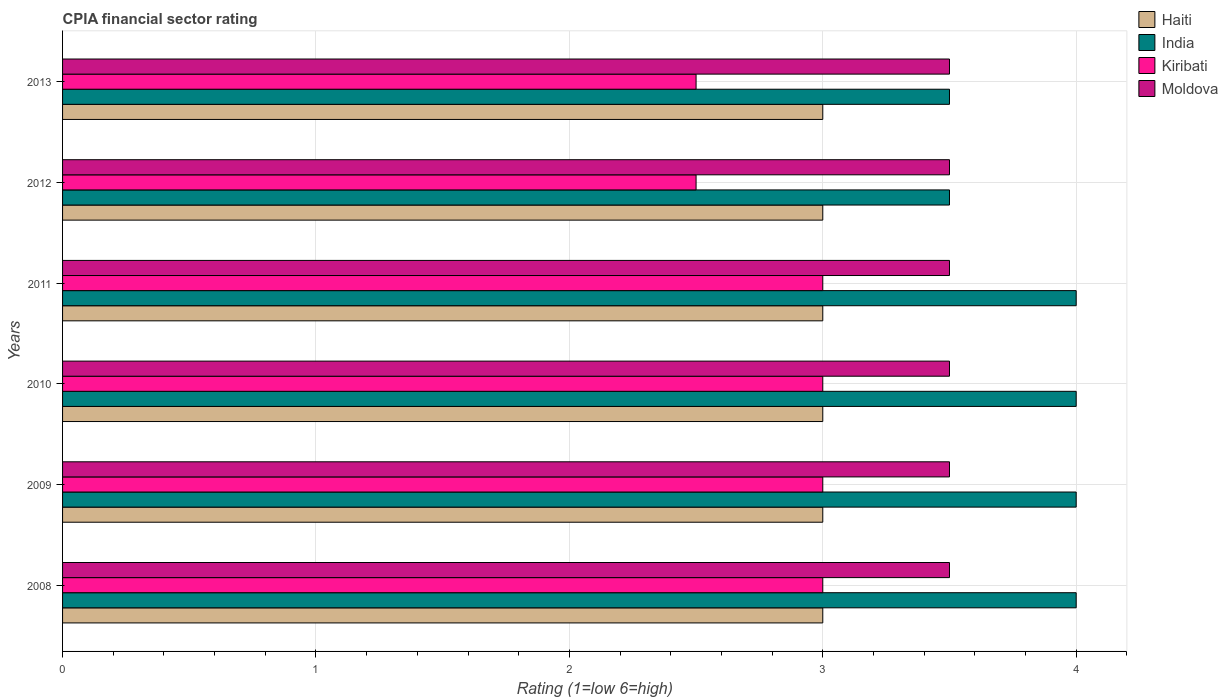How many different coloured bars are there?
Offer a very short reply. 4. Are the number of bars on each tick of the Y-axis equal?
Your answer should be very brief. Yes. What is the label of the 3rd group of bars from the top?
Offer a very short reply. 2011. In how many cases, is the number of bars for a given year not equal to the number of legend labels?
Offer a terse response. 0. What is the CPIA rating in Haiti in 2010?
Give a very brief answer. 3. Across all years, what is the maximum CPIA rating in Haiti?
Offer a very short reply. 3. Across all years, what is the minimum CPIA rating in Haiti?
Give a very brief answer. 3. In which year was the CPIA rating in Haiti maximum?
Your answer should be compact. 2008. In which year was the CPIA rating in Haiti minimum?
Offer a very short reply. 2008. What is the total CPIA rating in Haiti in the graph?
Your response must be concise. 18. What is the difference between the CPIA rating in India in 2010 and the CPIA rating in Kiribati in 2011?
Your response must be concise. 1. What is the average CPIA rating in India per year?
Offer a terse response. 3.83. In how many years, is the CPIA rating in Kiribati greater than 2 ?
Provide a short and direct response. 6. What is the ratio of the CPIA rating in India in 2010 to that in 2012?
Provide a succinct answer. 1.14. Is the CPIA rating in Haiti in 2011 less than that in 2012?
Give a very brief answer. No. Is the difference between the CPIA rating in Moldova in 2010 and 2011 greater than the difference between the CPIA rating in Kiribati in 2010 and 2011?
Ensure brevity in your answer.  No. What does the 4th bar from the top in 2010 represents?
Your answer should be very brief. Haiti. What does the 4th bar from the bottom in 2008 represents?
Give a very brief answer. Moldova. Is it the case that in every year, the sum of the CPIA rating in Moldova and CPIA rating in Haiti is greater than the CPIA rating in Kiribati?
Your answer should be very brief. Yes. Are all the bars in the graph horizontal?
Provide a short and direct response. Yes. How many years are there in the graph?
Make the answer very short. 6. Are the values on the major ticks of X-axis written in scientific E-notation?
Offer a very short reply. No. Where does the legend appear in the graph?
Make the answer very short. Top right. What is the title of the graph?
Give a very brief answer. CPIA financial sector rating. What is the Rating (1=low 6=high) in Kiribati in 2008?
Offer a very short reply. 3. What is the Rating (1=low 6=high) of Haiti in 2009?
Provide a short and direct response. 3. What is the Rating (1=low 6=high) of Moldova in 2009?
Ensure brevity in your answer.  3.5. What is the Rating (1=low 6=high) in Kiribati in 2010?
Provide a succinct answer. 3. What is the Rating (1=low 6=high) of Moldova in 2010?
Give a very brief answer. 3.5. What is the Rating (1=low 6=high) of Haiti in 2011?
Provide a succinct answer. 3. What is the Rating (1=low 6=high) of India in 2011?
Your response must be concise. 4. What is the Rating (1=low 6=high) in India in 2012?
Provide a succinct answer. 3.5. What is the Rating (1=low 6=high) of Kiribati in 2012?
Ensure brevity in your answer.  2.5. What is the Rating (1=low 6=high) of Moldova in 2012?
Provide a short and direct response. 3.5. What is the Rating (1=low 6=high) of Haiti in 2013?
Give a very brief answer. 3. What is the Rating (1=low 6=high) in India in 2013?
Offer a very short reply. 3.5. What is the Rating (1=low 6=high) in Kiribati in 2013?
Give a very brief answer. 2.5. What is the Rating (1=low 6=high) of Moldova in 2013?
Ensure brevity in your answer.  3.5. Across all years, what is the maximum Rating (1=low 6=high) of India?
Your answer should be compact. 4. Across all years, what is the maximum Rating (1=low 6=high) in Kiribati?
Offer a very short reply. 3. Across all years, what is the minimum Rating (1=low 6=high) of India?
Provide a short and direct response. 3.5. What is the total Rating (1=low 6=high) of India in the graph?
Keep it short and to the point. 23. What is the difference between the Rating (1=low 6=high) of India in 2008 and that in 2009?
Make the answer very short. 0. What is the difference between the Rating (1=low 6=high) of India in 2008 and that in 2010?
Your response must be concise. 0. What is the difference between the Rating (1=low 6=high) in Moldova in 2008 and that in 2010?
Offer a terse response. 0. What is the difference between the Rating (1=low 6=high) in India in 2008 and that in 2011?
Ensure brevity in your answer.  0. What is the difference between the Rating (1=low 6=high) in India in 2008 and that in 2012?
Provide a succinct answer. 0.5. What is the difference between the Rating (1=low 6=high) of Moldova in 2008 and that in 2012?
Provide a short and direct response. 0. What is the difference between the Rating (1=low 6=high) in India in 2008 and that in 2013?
Keep it short and to the point. 0.5. What is the difference between the Rating (1=low 6=high) of Haiti in 2009 and that in 2010?
Provide a succinct answer. 0. What is the difference between the Rating (1=low 6=high) in India in 2009 and that in 2010?
Offer a terse response. 0. What is the difference between the Rating (1=low 6=high) of India in 2009 and that in 2011?
Provide a succinct answer. 0. What is the difference between the Rating (1=low 6=high) in Haiti in 2009 and that in 2012?
Keep it short and to the point. 0. What is the difference between the Rating (1=low 6=high) of India in 2009 and that in 2012?
Your answer should be very brief. 0.5. What is the difference between the Rating (1=low 6=high) of Moldova in 2009 and that in 2012?
Your answer should be compact. 0. What is the difference between the Rating (1=low 6=high) in Haiti in 2009 and that in 2013?
Offer a very short reply. 0. What is the difference between the Rating (1=low 6=high) of India in 2009 and that in 2013?
Offer a terse response. 0.5. What is the difference between the Rating (1=low 6=high) in Kiribati in 2009 and that in 2013?
Your answer should be very brief. 0.5. What is the difference between the Rating (1=low 6=high) of Moldova in 2009 and that in 2013?
Your response must be concise. 0. What is the difference between the Rating (1=low 6=high) in Haiti in 2010 and that in 2011?
Your answer should be very brief. 0. What is the difference between the Rating (1=low 6=high) in India in 2010 and that in 2011?
Provide a succinct answer. 0. What is the difference between the Rating (1=low 6=high) of Moldova in 2010 and that in 2011?
Ensure brevity in your answer.  0. What is the difference between the Rating (1=low 6=high) in Haiti in 2010 and that in 2012?
Keep it short and to the point. 0. What is the difference between the Rating (1=low 6=high) of India in 2010 and that in 2013?
Give a very brief answer. 0.5. What is the difference between the Rating (1=low 6=high) of Haiti in 2011 and that in 2012?
Your response must be concise. 0. What is the difference between the Rating (1=low 6=high) in Kiribati in 2011 and that in 2012?
Your answer should be very brief. 0.5. What is the difference between the Rating (1=low 6=high) of India in 2011 and that in 2013?
Provide a short and direct response. 0.5. What is the difference between the Rating (1=low 6=high) of Moldova in 2011 and that in 2013?
Keep it short and to the point. 0. What is the difference between the Rating (1=low 6=high) of India in 2012 and that in 2013?
Keep it short and to the point. 0. What is the difference between the Rating (1=low 6=high) of India in 2008 and the Rating (1=low 6=high) of Kiribati in 2009?
Your answer should be compact. 1. What is the difference between the Rating (1=low 6=high) of Kiribati in 2008 and the Rating (1=low 6=high) of Moldova in 2009?
Provide a succinct answer. -0.5. What is the difference between the Rating (1=low 6=high) in Haiti in 2008 and the Rating (1=low 6=high) in India in 2010?
Offer a very short reply. -1. What is the difference between the Rating (1=low 6=high) of Haiti in 2008 and the Rating (1=low 6=high) of Kiribati in 2010?
Ensure brevity in your answer.  0. What is the difference between the Rating (1=low 6=high) of India in 2008 and the Rating (1=low 6=high) of Kiribati in 2010?
Provide a short and direct response. 1. What is the difference between the Rating (1=low 6=high) in Kiribati in 2008 and the Rating (1=low 6=high) in Moldova in 2010?
Provide a short and direct response. -0.5. What is the difference between the Rating (1=low 6=high) in Haiti in 2008 and the Rating (1=low 6=high) in India in 2011?
Give a very brief answer. -1. What is the difference between the Rating (1=low 6=high) of Haiti in 2008 and the Rating (1=low 6=high) of Moldova in 2011?
Your answer should be very brief. -0.5. What is the difference between the Rating (1=low 6=high) in India in 2008 and the Rating (1=low 6=high) in Kiribati in 2011?
Offer a terse response. 1. What is the difference between the Rating (1=low 6=high) of Kiribati in 2008 and the Rating (1=low 6=high) of Moldova in 2011?
Ensure brevity in your answer.  -0.5. What is the difference between the Rating (1=low 6=high) in India in 2008 and the Rating (1=low 6=high) in Kiribati in 2012?
Your response must be concise. 1.5. What is the difference between the Rating (1=low 6=high) in Kiribati in 2008 and the Rating (1=low 6=high) in Moldova in 2012?
Give a very brief answer. -0.5. What is the difference between the Rating (1=low 6=high) of Haiti in 2008 and the Rating (1=low 6=high) of Kiribati in 2013?
Offer a terse response. 0.5. What is the difference between the Rating (1=low 6=high) of Haiti in 2009 and the Rating (1=low 6=high) of India in 2010?
Keep it short and to the point. -1. What is the difference between the Rating (1=low 6=high) of Haiti in 2009 and the Rating (1=low 6=high) of Kiribati in 2010?
Provide a succinct answer. 0. What is the difference between the Rating (1=low 6=high) in India in 2009 and the Rating (1=low 6=high) in Kiribati in 2010?
Your answer should be compact. 1. What is the difference between the Rating (1=low 6=high) in India in 2009 and the Rating (1=low 6=high) in Moldova in 2010?
Offer a terse response. 0.5. What is the difference between the Rating (1=low 6=high) in Kiribati in 2009 and the Rating (1=low 6=high) in Moldova in 2010?
Make the answer very short. -0.5. What is the difference between the Rating (1=low 6=high) of Haiti in 2009 and the Rating (1=low 6=high) of India in 2011?
Keep it short and to the point. -1. What is the difference between the Rating (1=low 6=high) of Haiti in 2009 and the Rating (1=low 6=high) of India in 2012?
Offer a very short reply. -0.5. What is the difference between the Rating (1=low 6=high) in Haiti in 2009 and the Rating (1=low 6=high) in Moldova in 2012?
Provide a succinct answer. -0.5. What is the difference between the Rating (1=low 6=high) of India in 2009 and the Rating (1=low 6=high) of Kiribati in 2012?
Make the answer very short. 1.5. What is the difference between the Rating (1=low 6=high) of Haiti in 2009 and the Rating (1=low 6=high) of India in 2013?
Give a very brief answer. -0.5. What is the difference between the Rating (1=low 6=high) in Haiti in 2009 and the Rating (1=low 6=high) in Kiribati in 2013?
Your answer should be compact. 0.5. What is the difference between the Rating (1=low 6=high) in Haiti in 2009 and the Rating (1=low 6=high) in Moldova in 2013?
Provide a succinct answer. -0.5. What is the difference between the Rating (1=low 6=high) of India in 2009 and the Rating (1=low 6=high) of Kiribati in 2013?
Keep it short and to the point. 1.5. What is the difference between the Rating (1=low 6=high) of India in 2009 and the Rating (1=low 6=high) of Moldova in 2013?
Your answer should be compact. 0.5. What is the difference between the Rating (1=low 6=high) in Kiribati in 2009 and the Rating (1=low 6=high) in Moldova in 2013?
Give a very brief answer. -0.5. What is the difference between the Rating (1=low 6=high) of Haiti in 2010 and the Rating (1=low 6=high) of Kiribati in 2011?
Your response must be concise. 0. What is the difference between the Rating (1=low 6=high) of India in 2010 and the Rating (1=low 6=high) of Kiribati in 2011?
Provide a short and direct response. 1. What is the difference between the Rating (1=low 6=high) in Haiti in 2010 and the Rating (1=low 6=high) in India in 2012?
Your answer should be very brief. -0.5. What is the difference between the Rating (1=low 6=high) of Haiti in 2010 and the Rating (1=low 6=high) of Moldova in 2013?
Make the answer very short. -0.5. What is the difference between the Rating (1=low 6=high) of Haiti in 2011 and the Rating (1=low 6=high) of Moldova in 2012?
Offer a very short reply. -0.5. What is the difference between the Rating (1=low 6=high) in India in 2011 and the Rating (1=low 6=high) in Kiribati in 2012?
Keep it short and to the point. 1.5. What is the difference between the Rating (1=low 6=high) of India in 2011 and the Rating (1=low 6=high) of Moldova in 2012?
Your response must be concise. 0.5. What is the difference between the Rating (1=low 6=high) in Haiti in 2011 and the Rating (1=low 6=high) in India in 2013?
Ensure brevity in your answer.  -0.5. What is the difference between the Rating (1=low 6=high) of India in 2011 and the Rating (1=low 6=high) of Kiribati in 2013?
Provide a succinct answer. 1.5. What is the difference between the Rating (1=low 6=high) in Kiribati in 2011 and the Rating (1=low 6=high) in Moldova in 2013?
Offer a very short reply. -0.5. What is the difference between the Rating (1=low 6=high) of Haiti in 2012 and the Rating (1=low 6=high) of Kiribati in 2013?
Your answer should be very brief. 0.5. What is the difference between the Rating (1=low 6=high) of Haiti in 2012 and the Rating (1=low 6=high) of Moldova in 2013?
Offer a very short reply. -0.5. What is the difference between the Rating (1=low 6=high) in India in 2012 and the Rating (1=low 6=high) in Kiribati in 2013?
Your response must be concise. 1. What is the difference between the Rating (1=low 6=high) of Kiribati in 2012 and the Rating (1=low 6=high) of Moldova in 2013?
Provide a succinct answer. -1. What is the average Rating (1=low 6=high) of India per year?
Provide a succinct answer. 3.83. What is the average Rating (1=low 6=high) in Kiribati per year?
Keep it short and to the point. 2.83. What is the average Rating (1=low 6=high) in Moldova per year?
Offer a very short reply. 3.5. In the year 2008, what is the difference between the Rating (1=low 6=high) in Haiti and Rating (1=low 6=high) in Kiribati?
Give a very brief answer. 0. In the year 2008, what is the difference between the Rating (1=low 6=high) of Haiti and Rating (1=low 6=high) of Moldova?
Your answer should be very brief. -0.5. In the year 2008, what is the difference between the Rating (1=low 6=high) in India and Rating (1=low 6=high) in Kiribati?
Provide a succinct answer. 1. In the year 2008, what is the difference between the Rating (1=low 6=high) of India and Rating (1=low 6=high) of Moldova?
Make the answer very short. 0.5. In the year 2009, what is the difference between the Rating (1=low 6=high) in Haiti and Rating (1=low 6=high) in Moldova?
Provide a short and direct response. -0.5. In the year 2009, what is the difference between the Rating (1=low 6=high) of Kiribati and Rating (1=low 6=high) of Moldova?
Ensure brevity in your answer.  -0.5. In the year 2010, what is the difference between the Rating (1=low 6=high) in Haiti and Rating (1=low 6=high) in India?
Offer a very short reply. -1. In the year 2010, what is the difference between the Rating (1=low 6=high) in Haiti and Rating (1=low 6=high) in Moldova?
Your answer should be very brief. -0.5. In the year 2010, what is the difference between the Rating (1=low 6=high) of India and Rating (1=low 6=high) of Kiribati?
Ensure brevity in your answer.  1. In the year 2011, what is the difference between the Rating (1=low 6=high) of Haiti and Rating (1=low 6=high) of India?
Keep it short and to the point. -1. In the year 2011, what is the difference between the Rating (1=low 6=high) in Haiti and Rating (1=low 6=high) in Moldova?
Keep it short and to the point. -0.5. In the year 2012, what is the difference between the Rating (1=low 6=high) of Haiti and Rating (1=low 6=high) of India?
Make the answer very short. -0.5. In the year 2012, what is the difference between the Rating (1=low 6=high) of Haiti and Rating (1=low 6=high) of Kiribati?
Ensure brevity in your answer.  0.5. In the year 2012, what is the difference between the Rating (1=low 6=high) of India and Rating (1=low 6=high) of Moldova?
Give a very brief answer. 0. In the year 2013, what is the difference between the Rating (1=low 6=high) of Haiti and Rating (1=low 6=high) of Kiribati?
Offer a very short reply. 0.5. In the year 2013, what is the difference between the Rating (1=low 6=high) of Haiti and Rating (1=low 6=high) of Moldova?
Give a very brief answer. -0.5. What is the ratio of the Rating (1=low 6=high) in Haiti in 2008 to that in 2009?
Give a very brief answer. 1. What is the ratio of the Rating (1=low 6=high) in India in 2008 to that in 2009?
Offer a very short reply. 1. What is the ratio of the Rating (1=low 6=high) of Kiribati in 2008 to that in 2009?
Offer a very short reply. 1. What is the ratio of the Rating (1=low 6=high) in India in 2008 to that in 2010?
Offer a terse response. 1. What is the ratio of the Rating (1=low 6=high) of Moldova in 2008 to that in 2010?
Offer a very short reply. 1. What is the ratio of the Rating (1=low 6=high) of Moldova in 2008 to that in 2011?
Give a very brief answer. 1. What is the ratio of the Rating (1=low 6=high) of Haiti in 2008 to that in 2012?
Your response must be concise. 1. What is the ratio of the Rating (1=low 6=high) in Kiribati in 2008 to that in 2012?
Provide a succinct answer. 1.2. What is the ratio of the Rating (1=low 6=high) of Haiti in 2008 to that in 2013?
Give a very brief answer. 1. What is the ratio of the Rating (1=low 6=high) in India in 2008 to that in 2013?
Give a very brief answer. 1.14. What is the ratio of the Rating (1=low 6=high) in Moldova in 2008 to that in 2013?
Keep it short and to the point. 1. What is the ratio of the Rating (1=low 6=high) of India in 2009 to that in 2010?
Offer a terse response. 1. What is the ratio of the Rating (1=low 6=high) of Kiribati in 2009 to that in 2010?
Make the answer very short. 1. What is the ratio of the Rating (1=low 6=high) in Moldova in 2009 to that in 2010?
Keep it short and to the point. 1. What is the ratio of the Rating (1=low 6=high) in Moldova in 2009 to that in 2011?
Your answer should be very brief. 1. What is the ratio of the Rating (1=low 6=high) of Haiti in 2009 to that in 2012?
Make the answer very short. 1. What is the ratio of the Rating (1=low 6=high) in India in 2009 to that in 2012?
Offer a very short reply. 1.14. What is the ratio of the Rating (1=low 6=high) of Kiribati in 2009 to that in 2012?
Your answer should be very brief. 1.2. What is the ratio of the Rating (1=low 6=high) of Haiti in 2009 to that in 2013?
Offer a very short reply. 1. What is the ratio of the Rating (1=low 6=high) of Moldova in 2009 to that in 2013?
Provide a succinct answer. 1. What is the ratio of the Rating (1=low 6=high) in Moldova in 2010 to that in 2011?
Provide a succinct answer. 1. What is the ratio of the Rating (1=low 6=high) of India in 2010 to that in 2012?
Offer a very short reply. 1.14. What is the ratio of the Rating (1=low 6=high) of Moldova in 2010 to that in 2012?
Give a very brief answer. 1. What is the ratio of the Rating (1=low 6=high) in Haiti in 2011 to that in 2012?
Ensure brevity in your answer.  1. What is the ratio of the Rating (1=low 6=high) in Haiti in 2011 to that in 2013?
Provide a succinct answer. 1. What is the ratio of the Rating (1=low 6=high) in India in 2011 to that in 2013?
Ensure brevity in your answer.  1.14. What is the ratio of the Rating (1=low 6=high) in Kiribati in 2011 to that in 2013?
Your response must be concise. 1.2. What is the ratio of the Rating (1=low 6=high) in Haiti in 2012 to that in 2013?
Provide a succinct answer. 1. What is the ratio of the Rating (1=low 6=high) of India in 2012 to that in 2013?
Make the answer very short. 1. What is the ratio of the Rating (1=low 6=high) of Kiribati in 2012 to that in 2013?
Your answer should be compact. 1. What is the difference between the highest and the second highest Rating (1=low 6=high) of Haiti?
Offer a terse response. 0. What is the difference between the highest and the second highest Rating (1=low 6=high) of India?
Provide a short and direct response. 0. What is the difference between the highest and the second highest Rating (1=low 6=high) in Moldova?
Offer a terse response. 0. What is the difference between the highest and the lowest Rating (1=low 6=high) in Haiti?
Make the answer very short. 0. What is the difference between the highest and the lowest Rating (1=low 6=high) in Moldova?
Keep it short and to the point. 0. 